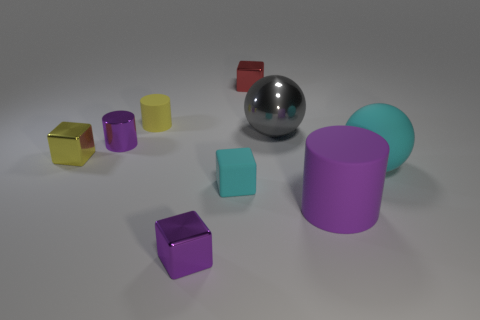What can you say about the distribution of colors among the objects? The objects showcase a variety of colors including gold, silver, purple, cyan, and yellow. Each color is represented at least once, and the shades of purple and cyan vary among different objects. 